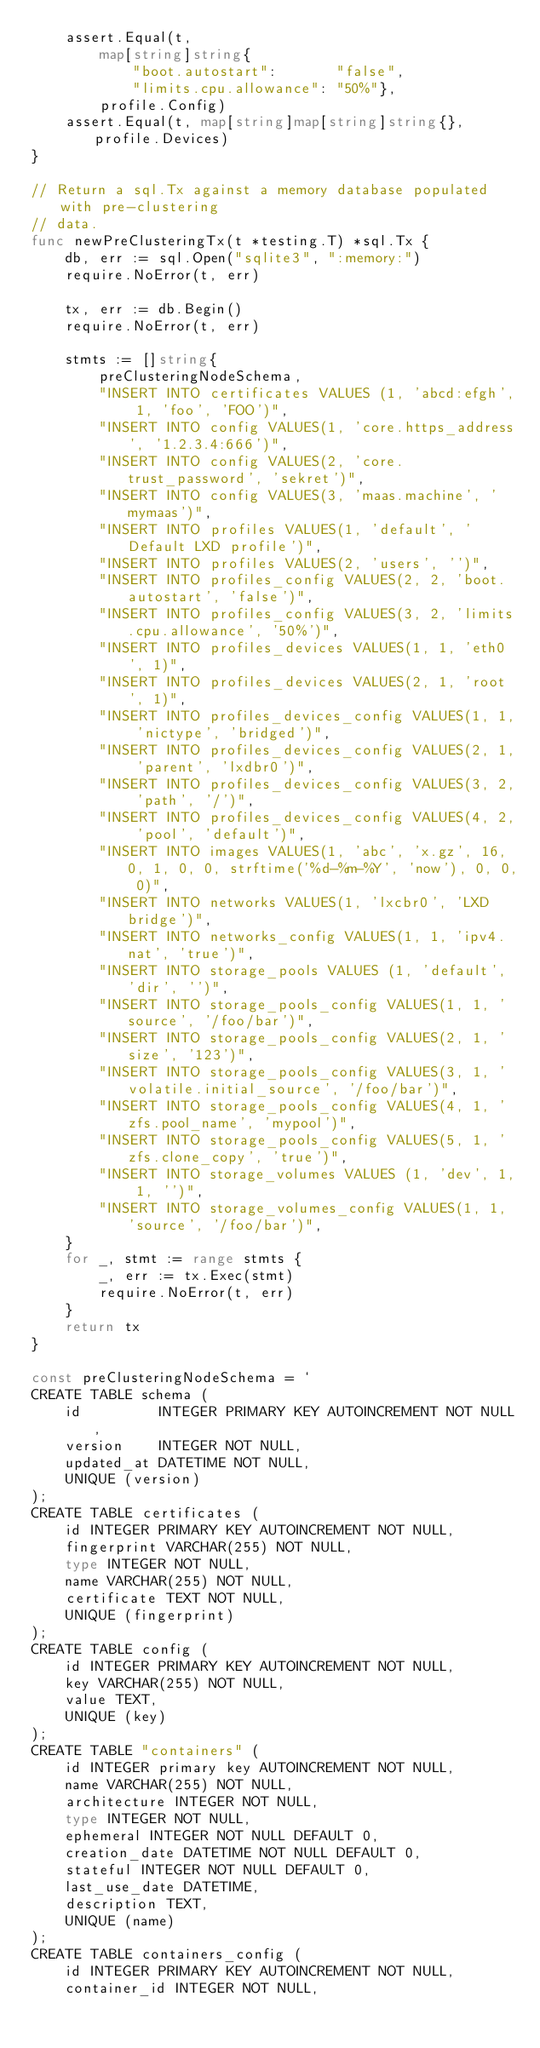<code> <loc_0><loc_0><loc_500><loc_500><_Go_>	assert.Equal(t,
		map[string]string{
			"boot.autostart":       "false",
			"limits.cpu.allowance": "50%"},
		profile.Config)
	assert.Equal(t, map[string]map[string]string{}, profile.Devices)
}

// Return a sql.Tx against a memory database populated with pre-clustering
// data.
func newPreClusteringTx(t *testing.T) *sql.Tx {
	db, err := sql.Open("sqlite3", ":memory:")
	require.NoError(t, err)

	tx, err := db.Begin()
	require.NoError(t, err)

	stmts := []string{
		preClusteringNodeSchema,
		"INSERT INTO certificates VALUES (1, 'abcd:efgh', 1, 'foo', 'FOO')",
		"INSERT INTO config VALUES(1, 'core.https_address', '1.2.3.4:666')",
		"INSERT INTO config VALUES(2, 'core.trust_password', 'sekret')",
		"INSERT INTO config VALUES(3, 'maas.machine', 'mymaas')",
		"INSERT INTO profiles VALUES(1, 'default', 'Default LXD profile')",
		"INSERT INTO profiles VALUES(2, 'users', '')",
		"INSERT INTO profiles_config VALUES(2, 2, 'boot.autostart', 'false')",
		"INSERT INTO profiles_config VALUES(3, 2, 'limits.cpu.allowance', '50%')",
		"INSERT INTO profiles_devices VALUES(1, 1, 'eth0', 1)",
		"INSERT INTO profiles_devices VALUES(2, 1, 'root', 1)",
		"INSERT INTO profiles_devices_config VALUES(1, 1, 'nictype', 'bridged')",
		"INSERT INTO profiles_devices_config VALUES(2, 1, 'parent', 'lxdbr0')",
		"INSERT INTO profiles_devices_config VALUES(3, 2, 'path', '/')",
		"INSERT INTO profiles_devices_config VALUES(4, 2, 'pool', 'default')",
		"INSERT INTO images VALUES(1, 'abc', 'x.gz', 16, 0, 1, 0, 0, strftime('%d-%m-%Y', 'now'), 0, 0, 0)",
		"INSERT INTO networks VALUES(1, 'lxcbr0', 'LXD bridge')",
		"INSERT INTO networks_config VALUES(1, 1, 'ipv4.nat', 'true')",
		"INSERT INTO storage_pools VALUES (1, 'default', 'dir', '')",
		"INSERT INTO storage_pools_config VALUES(1, 1, 'source', '/foo/bar')",
		"INSERT INTO storage_pools_config VALUES(2, 1, 'size', '123')",
		"INSERT INTO storage_pools_config VALUES(3, 1, 'volatile.initial_source', '/foo/bar')",
		"INSERT INTO storage_pools_config VALUES(4, 1, 'zfs.pool_name', 'mypool')",
		"INSERT INTO storage_pools_config VALUES(5, 1, 'zfs.clone_copy', 'true')",
		"INSERT INTO storage_volumes VALUES (1, 'dev', 1, 1, '')",
		"INSERT INTO storage_volumes_config VALUES(1, 1, 'source', '/foo/bar')",
	}
	for _, stmt := range stmts {
		_, err := tx.Exec(stmt)
		require.NoError(t, err)
	}
	return tx
}

const preClusteringNodeSchema = `
CREATE TABLE schema (
    id         INTEGER PRIMARY KEY AUTOINCREMENT NOT NULL,
    version    INTEGER NOT NULL,
    updated_at DATETIME NOT NULL,
    UNIQUE (version)
);
CREATE TABLE certificates (
    id INTEGER PRIMARY KEY AUTOINCREMENT NOT NULL,
    fingerprint VARCHAR(255) NOT NULL,
    type INTEGER NOT NULL,
    name VARCHAR(255) NOT NULL,
    certificate TEXT NOT NULL,
    UNIQUE (fingerprint)
);
CREATE TABLE config (
    id INTEGER PRIMARY KEY AUTOINCREMENT NOT NULL,
    key VARCHAR(255) NOT NULL,
    value TEXT,
    UNIQUE (key)
);
CREATE TABLE "containers" (
    id INTEGER primary key AUTOINCREMENT NOT NULL,
    name VARCHAR(255) NOT NULL,
    architecture INTEGER NOT NULL,
    type INTEGER NOT NULL,
    ephemeral INTEGER NOT NULL DEFAULT 0,
    creation_date DATETIME NOT NULL DEFAULT 0,
    stateful INTEGER NOT NULL DEFAULT 0,
    last_use_date DATETIME,
    description TEXT,
    UNIQUE (name)
);
CREATE TABLE containers_config (
    id INTEGER PRIMARY KEY AUTOINCREMENT NOT NULL,
    container_id INTEGER NOT NULL,</code> 